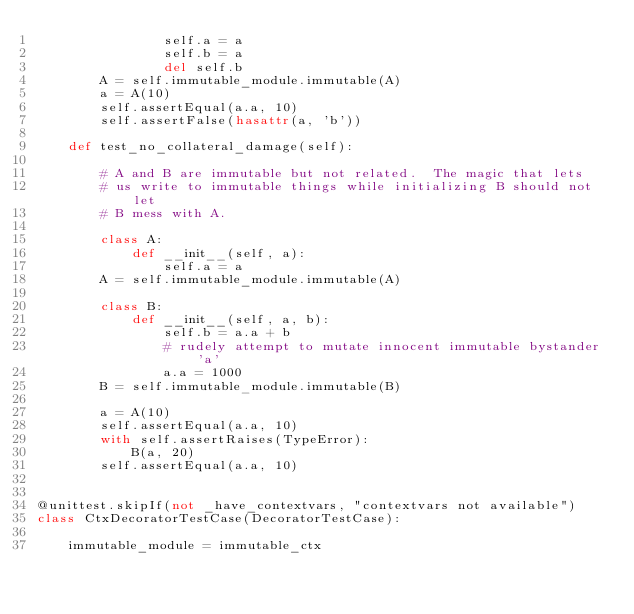<code> <loc_0><loc_0><loc_500><loc_500><_Python_>                self.a = a
                self.b = a
                del self.b
        A = self.immutable_module.immutable(A)
        a = A(10)
        self.assertEqual(a.a, 10)
        self.assertFalse(hasattr(a, 'b'))

    def test_no_collateral_damage(self):

        # A and B are immutable but not related.  The magic that lets
        # us write to immutable things while initializing B should not let
        # B mess with A.

        class A:
            def __init__(self, a):
                self.a = a
        A = self.immutable_module.immutable(A)

        class B:
            def __init__(self, a, b):
                self.b = a.a + b
                # rudely attempt to mutate innocent immutable bystander 'a'
                a.a = 1000
        B = self.immutable_module.immutable(B)

        a = A(10)
        self.assertEqual(a.a, 10)
        with self.assertRaises(TypeError):
            B(a, 20)
        self.assertEqual(a.a, 10)


@unittest.skipIf(not _have_contextvars, "contextvars not available")
class CtxDecoratorTestCase(DecoratorTestCase):

    immutable_module = immutable_ctx
</code> 